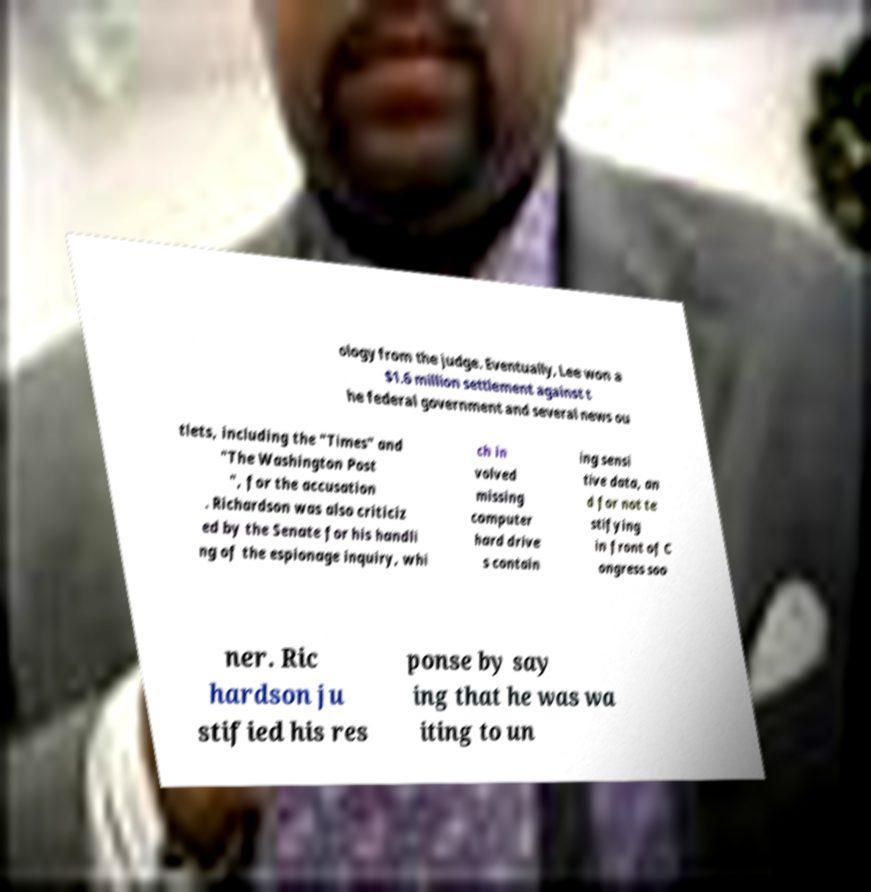There's text embedded in this image that I need extracted. Can you transcribe it verbatim? ology from the judge. Eventually, Lee won a $1.6 million settlement against t he federal government and several news ou tlets, including the "Times" and "The Washington Post ", for the accusation . Richardson was also criticiz ed by the Senate for his handli ng of the espionage inquiry, whi ch in volved missing computer hard drive s contain ing sensi tive data, an d for not te stifying in front of C ongress soo ner. Ric hardson ju stified his res ponse by say ing that he was wa iting to un 